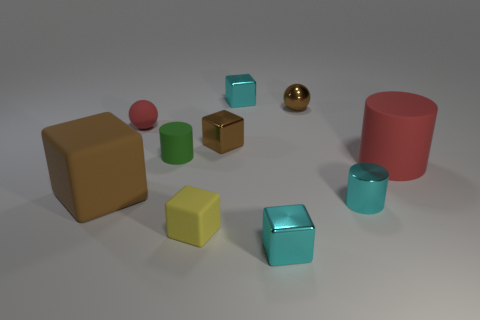What is the size of the red rubber object in front of the matte cylinder that is to the left of the big cylinder? The red rubber object appears to be relatively small in comparison to the nearby objects, such as the matte cylinder to its right and the larger cylinder adjacent to it. It seems to be medium-sized within the context of other similar objects in the scene. 